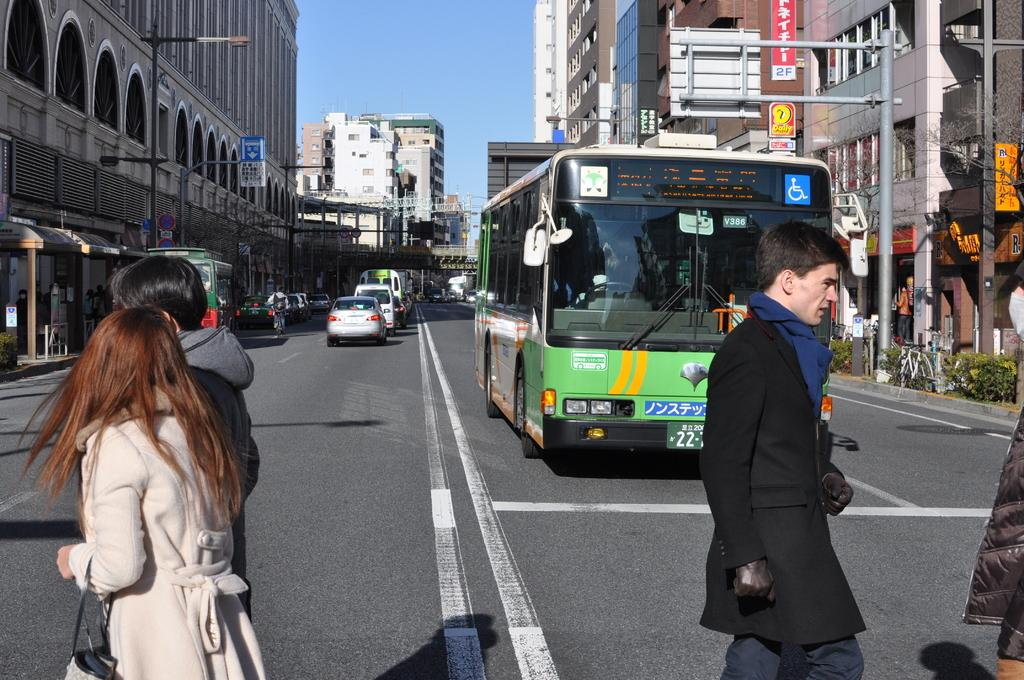<image>
Share a concise interpretation of the image provided. A bus approaching some people with the number 22 on the plate 